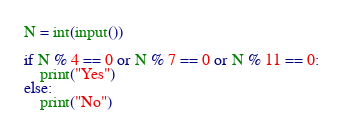Convert code to text. <code><loc_0><loc_0><loc_500><loc_500><_Python_>N = int(input())

if N % 4 == 0 or N % 7 == 0 or N % 11 == 0:
    print("Yes")
else:
    print("No")</code> 